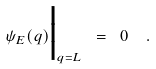Convert formula to latex. <formula><loc_0><loc_0><loc_500><loc_500>\psi _ { E } ( q ) \Big | _ { q = L } \ = \ 0 \ \ .</formula> 